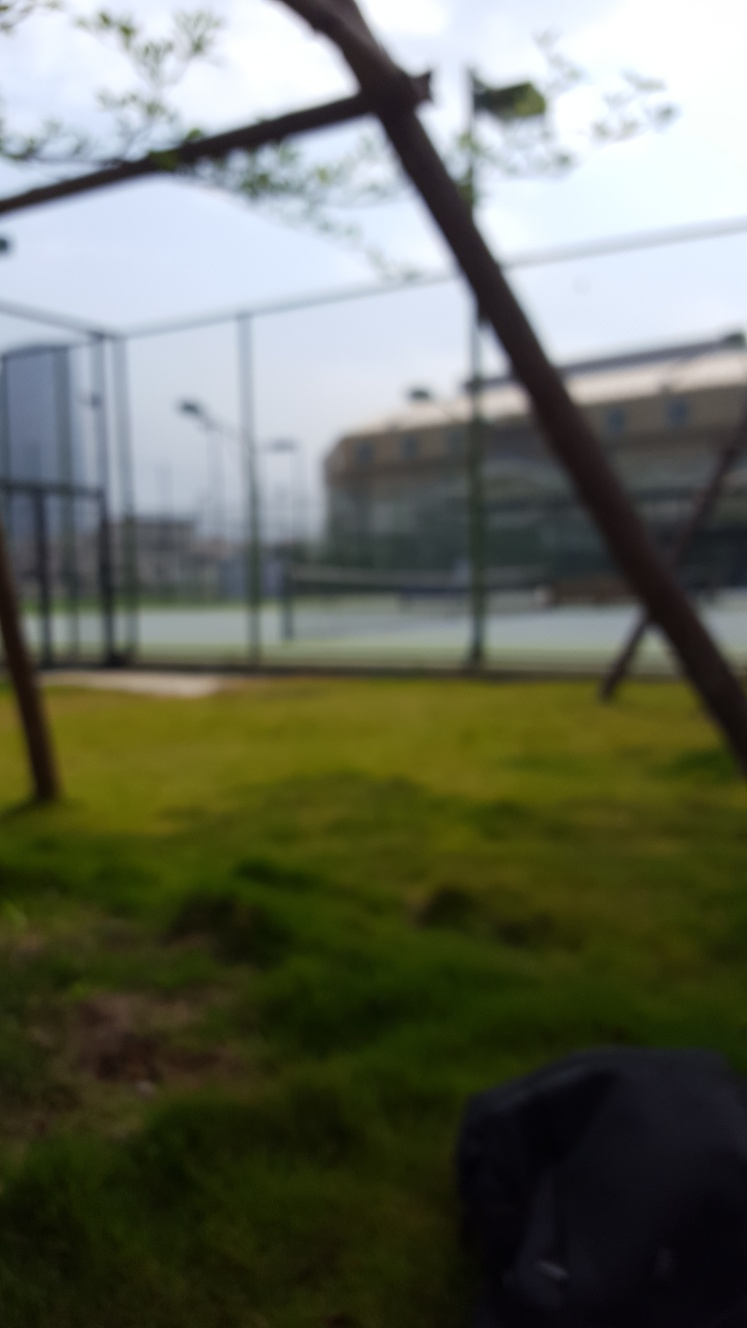Is there any indication of human activity present in this image? Due to the image's lack of clarity, any explicit signs of human activity are not immediately evident. However, the presence of what seems to be a sports court in the background might imply recent or potential human presence, as such facilities are commonly associated with recreational activities. 